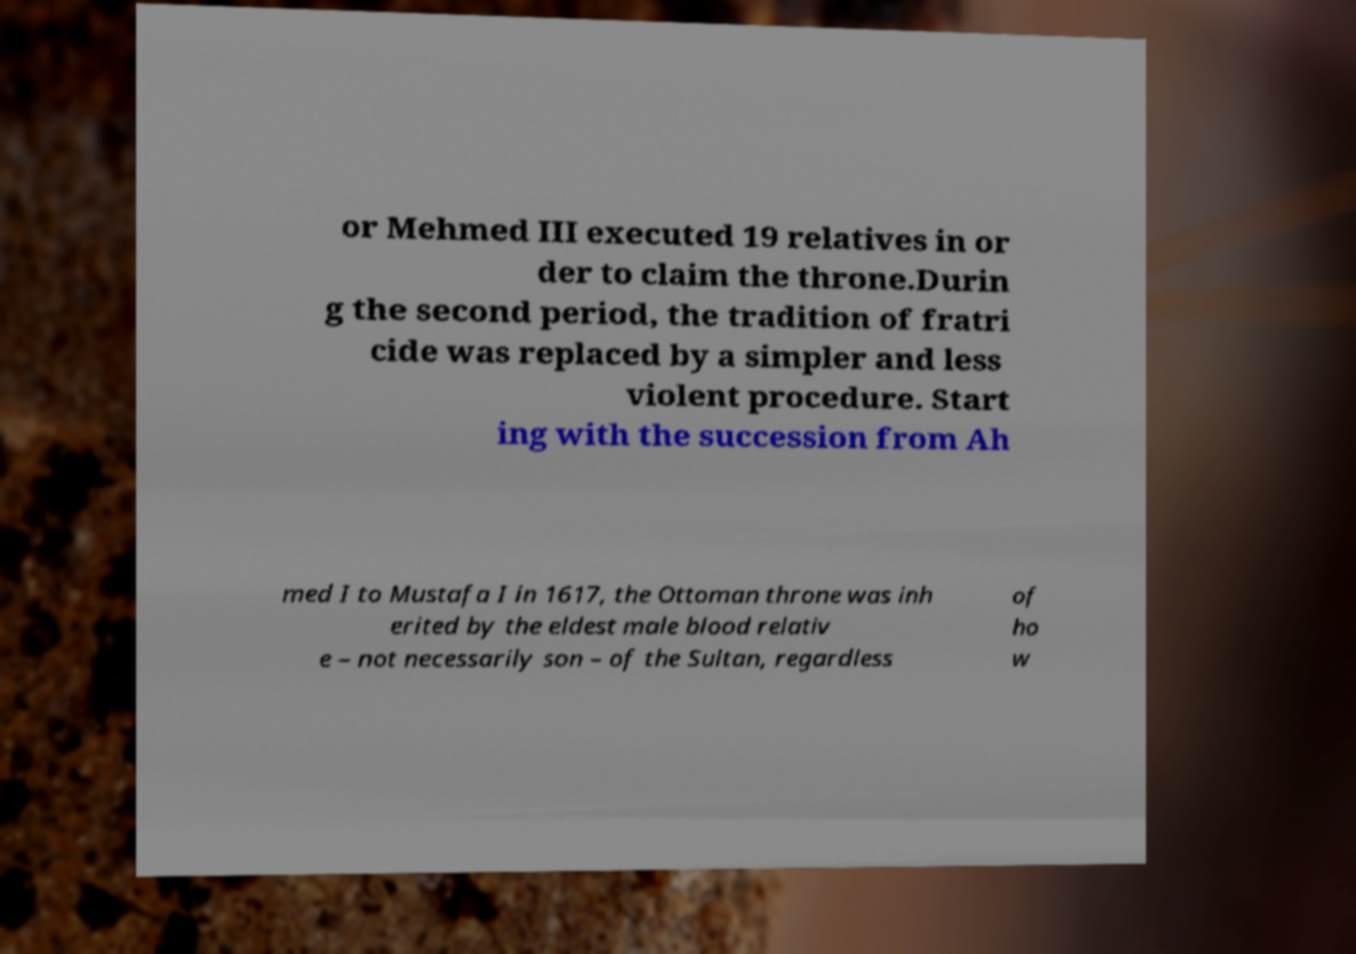What messages or text are displayed in this image? I need them in a readable, typed format. or Mehmed III executed 19 relatives in or der to claim the throne.Durin g the second period, the tradition of fratri cide was replaced by a simpler and less violent procedure. Start ing with the succession from Ah med I to Mustafa I in 1617, the Ottoman throne was inh erited by the eldest male blood relativ e – not necessarily son – of the Sultan, regardless of ho w 